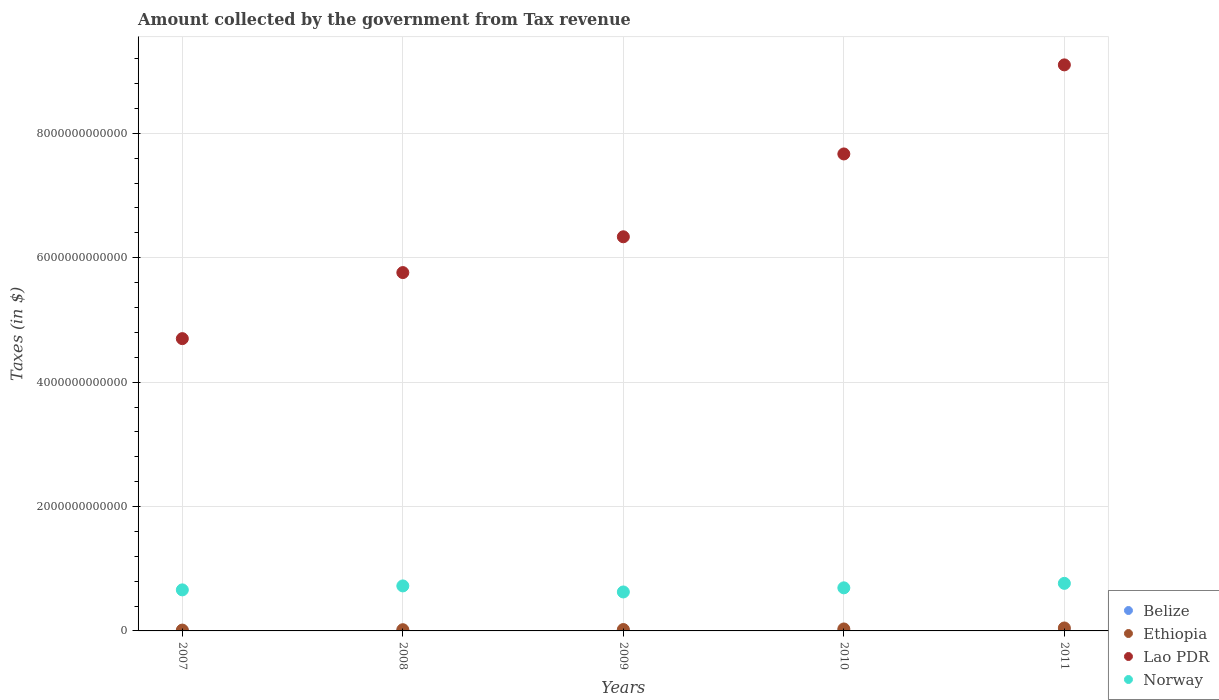How many different coloured dotlines are there?
Your answer should be very brief. 4. What is the amount collected by the government from tax revenue in Belize in 2010?
Provide a short and direct response. 6.59e+08. Across all years, what is the maximum amount collected by the government from tax revenue in Lao PDR?
Give a very brief answer. 9.10e+12. Across all years, what is the minimum amount collected by the government from tax revenue in Norway?
Offer a terse response. 6.26e+11. In which year was the amount collected by the government from tax revenue in Norway minimum?
Keep it short and to the point. 2009. What is the total amount collected by the government from tax revenue in Norway in the graph?
Your answer should be compact. 3.47e+12. What is the difference between the amount collected by the government from tax revenue in Ethiopia in 2009 and that in 2010?
Ensure brevity in your answer.  -9.26e+09. What is the difference between the amount collected by the government from tax revenue in Belize in 2011 and the amount collected by the government from tax revenue in Lao PDR in 2009?
Offer a terse response. -6.34e+12. What is the average amount collected by the government from tax revenue in Lao PDR per year?
Ensure brevity in your answer.  6.71e+12. In the year 2009, what is the difference between the amount collected by the government from tax revenue in Ethiopia and amount collected by the government from tax revenue in Lao PDR?
Your answer should be compact. -6.31e+12. What is the ratio of the amount collected by the government from tax revenue in Lao PDR in 2007 to that in 2010?
Give a very brief answer. 0.61. Is the difference between the amount collected by the government from tax revenue in Ethiopia in 2007 and 2011 greater than the difference between the amount collected by the government from tax revenue in Lao PDR in 2007 and 2011?
Offer a terse response. Yes. What is the difference between the highest and the second highest amount collected by the government from tax revenue in Lao PDR?
Make the answer very short. 1.43e+12. What is the difference between the highest and the lowest amount collected by the government from tax revenue in Belize?
Give a very brief answer. 7.95e+07. Is the sum of the amount collected by the government from tax revenue in Ethiopia in 2008 and 2009 greater than the maximum amount collected by the government from tax revenue in Belize across all years?
Make the answer very short. Yes. What is the difference between two consecutive major ticks on the Y-axis?
Your response must be concise. 2.00e+12. Are the values on the major ticks of Y-axis written in scientific E-notation?
Offer a very short reply. No. Does the graph contain any zero values?
Your answer should be compact. No. How many legend labels are there?
Your answer should be compact. 4. What is the title of the graph?
Ensure brevity in your answer.  Amount collected by the government from Tax revenue. What is the label or title of the X-axis?
Offer a terse response. Years. What is the label or title of the Y-axis?
Ensure brevity in your answer.  Taxes (in $). What is the Taxes (in $) in Belize in 2007?
Keep it short and to the point. 5.92e+08. What is the Taxes (in $) of Ethiopia in 2007?
Your response must be concise. 1.35e+1. What is the Taxes (in $) in Lao PDR in 2007?
Your answer should be compact. 4.70e+12. What is the Taxes (in $) of Norway in 2007?
Your answer should be very brief. 6.60e+11. What is the Taxes (in $) of Belize in 2008?
Provide a short and direct response. 5.94e+08. What is the Taxes (in $) of Ethiopia in 2008?
Give a very brief answer. 1.96e+1. What is the Taxes (in $) of Lao PDR in 2008?
Provide a short and direct response. 5.76e+12. What is the Taxes (in $) in Norway in 2008?
Make the answer very short. 7.24e+11. What is the Taxes (in $) of Belize in 2009?
Give a very brief answer. 6.01e+08. What is the Taxes (in $) of Ethiopia in 2009?
Offer a terse response. 2.22e+1. What is the Taxes (in $) in Lao PDR in 2009?
Offer a very short reply. 6.34e+12. What is the Taxes (in $) of Norway in 2009?
Your answer should be compact. 6.26e+11. What is the Taxes (in $) in Belize in 2010?
Provide a short and direct response. 6.59e+08. What is the Taxes (in $) in Ethiopia in 2010?
Your answer should be very brief. 3.15e+1. What is the Taxes (in $) in Lao PDR in 2010?
Your response must be concise. 7.67e+12. What is the Taxes (in $) of Norway in 2010?
Offer a terse response. 6.93e+11. What is the Taxes (in $) in Belize in 2011?
Offer a terse response. 6.71e+08. What is the Taxes (in $) in Ethiopia in 2011?
Ensure brevity in your answer.  4.74e+1. What is the Taxes (in $) of Lao PDR in 2011?
Give a very brief answer. 9.10e+12. What is the Taxes (in $) in Norway in 2011?
Your answer should be compact. 7.65e+11. Across all years, what is the maximum Taxes (in $) in Belize?
Make the answer very short. 6.71e+08. Across all years, what is the maximum Taxes (in $) of Ethiopia?
Make the answer very short. 4.74e+1. Across all years, what is the maximum Taxes (in $) of Lao PDR?
Your answer should be compact. 9.10e+12. Across all years, what is the maximum Taxes (in $) of Norway?
Provide a short and direct response. 7.65e+11. Across all years, what is the minimum Taxes (in $) in Belize?
Provide a short and direct response. 5.92e+08. Across all years, what is the minimum Taxes (in $) of Ethiopia?
Your response must be concise. 1.35e+1. Across all years, what is the minimum Taxes (in $) of Lao PDR?
Provide a short and direct response. 4.70e+12. Across all years, what is the minimum Taxes (in $) in Norway?
Ensure brevity in your answer.  6.26e+11. What is the total Taxes (in $) in Belize in the graph?
Offer a terse response. 3.12e+09. What is the total Taxes (in $) of Ethiopia in the graph?
Your response must be concise. 1.34e+11. What is the total Taxes (in $) of Lao PDR in the graph?
Provide a short and direct response. 3.36e+13. What is the total Taxes (in $) of Norway in the graph?
Provide a succinct answer. 3.47e+12. What is the difference between the Taxes (in $) in Belize in 2007 and that in 2008?
Your answer should be compact. -2.30e+06. What is the difference between the Taxes (in $) in Ethiopia in 2007 and that in 2008?
Offer a very short reply. -6.01e+09. What is the difference between the Taxes (in $) in Lao PDR in 2007 and that in 2008?
Ensure brevity in your answer.  -1.06e+12. What is the difference between the Taxes (in $) of Norway in 2007 and that in 2008?
Offer a very short reply. -6.36e+1. What is the difference between the Taxes (in $) in Belize in 2007 and that in 2009?
Give a very brief answer. -9.46e+06. What is the difference between the Taxes (in $) of Ethiopia in 2007 and that in 2009?
Ensure brevity in your answer.  -8.70e+09. What is the difference between the Taxes (in $) in Lao PDR in 2007 and that in 2009?
Your response must be concise. -1.64e+12. What is the difference between the Taxes (in $) of Norway in 2007 and that in 2009?
Keep it short and to the point. 3.35e+1. What is the difference between the Taxes (in $) of Belize in 2007 and that in 2010?
Provide a short and direct response. -6.77e+07. What is the difference between the Taxes (in $) in Ethiopia in 2007 and that in 2010?
Provide a succinct answer. -1.80e+1. What is the difference between the Taxes (in $) in Lao PDR in 2007 and that in 2010?
Make the answer very short. -2.97e+12. What is the difference between the Taxes (in $) in Norway in 2007 and that in 2010?
Give a very brief answer. -3.28e+1. What is the difference between the Taxes (in $) of Belize in 2007 and that in 2011?
Ensure brevity in your answer.  -7.95e+07. What is the difference between the Taxes (in $) of Ethiopia in 2007 and that in 2011?
Provide a short and direct response. -3.39e+1. What is the difference between the Taxes (in $) of Lao PDR in 2007 and that in 2011?
Provide a short and direct response. -4.40e+12. What is the difference between the Taxes (in $) in Norway in 2007 and that in 2011?
Keep it short and to the point. -1.05e+11. What is the difference between the Taxes (in $) in Belize in 2008 and that in 2009?
Your response must be concise. -7.17e+06. What is the difference between the Taxes (in $) in Ethiopia in 2008 and that in 2009?
Make the answer very short. -2.69e+09. What is the difference between the Taxes (in $) in Lao PDR in 2008 and that in 2009?
Ensure brevity in your answer.  -5.76e+11. What is the difference between the Taxes (in $) in Norway in 2008 and that in 2009?
Provide a short and direct response. 9.71e+1. What is the difference between the Taxes (in $) in Belize in 2008 and that in 2010?
Give a very brief answer. -6.54e+07. What is the difference between the Taxes (in $) of Ethiopia in 2008 and that in 2010?
Give a very brief answer. -1.19e+1. What is the difference between the Taxes (in $) of Lao PDR in 2008 and that in 2010?
Offer a terse response. -1.91e+12. What is the difference between the Taxes (in $) in Norway in 2008 and that in 2010?
Provide a short and direct response. 3.08e+1. What is the difference between the Taxes (in $) in Belize in 2008 and that in 2011?
Give a very brief answer. -7.72e+07. What is the difference between the Taxes (in $) in Ethiopia in 2008 and that in 2011?
Offer a very short reply. -2.79e+1. What is the difference between the Taxes (in $) of Lao PDR in 2008 and that in 2011?
Give a very brief answer. -3.34e+12. What is the difference between the Taxes (in $) of Norway in 2008 and that in 2011?
Your response must be concise. -4.12e+1. What is the difference between the Taxes (in $) of Belize in 2009 and that in 2010?
Ensure brevity in your answer.  -5.82e+07. What is the difference between the Taxes (in $) of Ethiopia in 2009 and that in 2010?
Offer a very short reply. -9.26e+09. What is the difference between the Taxes (in $) of Lao PDR in 2009 and that in 2010?
Your response must be concise. -1.33e+12. What is the difference between the Taxes (in $) in Norway in 2009 and that in 2010?
Provide a succinct answer. -6.63e+1. What is the difference between the Taxes (in $) in Belize in 2009 and that in 2011?
Keep it short and to the point. -7.00e+07. What is the difference between the Taxes (in $) of Ethiopia in 2009 and that in 2011?
Offer a very short reply. -2.52e+1. What is the difference between the Taxes (in $) in Lao PDR in 2009 and that in 2011?
Provide a short and direct response. -2.76e+12. What is the difference between the Taxes (in $) in Norway in 2009 and that in 2011?
Offer a terse response. -1.38e+11. What is the difference between the Taxes (in $) in Belize in 2010 and that in 2011?
Your answer should be compact. -1.18e+07. What is the difference between the Taxes (in $) of Ethiopia in 2010 and that in 2011?
Ensure brevity in your answer.  -1.59e+1. What is the difference between the Taxes (in $) of Lao PDR in 2010 and that in 2011?
Give a very brief answer. -1.43e+12. What is the difference between the Taxes (in $) of Norway in 2010 and that in 2011?
Provide a short and direct response. -7.20e+1. What is the difference between the Taxes (in $) in Belize in 2007 and the Taxes (in $) in Ethiopia in 2008?
Your answer should be compact. -1.90e+1. What is the difference between the Taxes (in $) of Belize in 2007 and the Taxes (in $) of Lao PDR in 2008?
Keep it short and to the point. -5.76e+12. What is the difference between the Taxes (in $) in Belize in 2007 and the Taxes (in $) in Norway in 2008?
Ensure brevity in your answer.  -7.23e+11. What is the difference between the Taxes (in $) of Ethiopia in 2007 and the Taxes (in $) of Lao PDR in 2008?
Ensure brevity in your answer.  -5.75e+12. What is the difference between the Taxes (in $) in Ethiopia in 2007 and the Taxes (in $) in Norway in 2008?
Your answer should be very brief. -7.10e+11. What is the difference between the Taxes (in $) in Lao PDR in 2007 and the Taxes (in $) in Norway in 2008?
Keep it short and to the point. 3.98e+12. What is the difference between the Taxes (in $) in Belize in 2007 and the Taxes (in $) in Ethiopia in 2009?
Offer a very short reply. -2.17e+1. What is the difference between the Taxes (in $) in Belize in 2007 and the Taxes (in $) in Lao PDR in 2009?
Make the answer very short. -6.34e+12. What is the difference between the Taxes (in $) in Belize in 2007 and the Taxes (in $) in Norway in 2009?
Offer a very short reply. -6.26e+11. What is the difference between the Taxes (in $) in Ethiopia in 2007 and the Taxes (in $) in Lao PDR in 2009?
Make the answer very short. -6.32e+12. What is the difference between the Taxes (in $) of Ethiopia in 2007 and the Taxes (in $) of Norway in 2009?
Offer a terse response. -6.13e+11. What is the difference between the Taxes (in $) of Lao PDR in 2007 and the Taxes (in $) of Norway in 2009?
Provide a succinct answer. 4.07e+12. What is the difference between the Taxes (in $) of Belize in 2007 and the Taxes (in $) of Ethiopia in 2010?
Ensure brevity in your answer.  -3.09e+1. What is the difference between the Taxes (in $) in Belize in 2007 and the Taxes (in $) in Lao PDR in 2010?
Make the answer very short. -7.67e+12. What is the difference between the Taxes (in $) of Belize in 2007 and the Taxes (in $) of Norway in 2010?
Offer a very short reply. -6.92e+11. What is the difference between the Taxes (in $) in Ethiopia in 2007 and the Taxes (in $) in Lao PDR in 2010?
Your response must be concise. -7.66e+12. What is the difference between the Taxes (in $) in Ethiopia in 2007 and the Taxes (in $) in Norway in 2010?
Ensure brevity in your answer.  -6.79e+11. What is the difference between the Taxes (in $) of Lao PDR in 2007 and the Taxes (in $) of Norway in 2010?
Your answer should be very brief. 4.01e+12. What is the difference between the Taxes (in $) in Belize in 2007 and the Taxes (in $) in Ethiopia in 2011?
Provide a succinct answer. -4.68e+1. What is the difference between the Taxes (in $) in Belize in 2007 and the Taxes (in $) in Lao PDR in 2011?
Ensure brevity in your answer.  -9.10e+12. What is the difference between the Taxes (in $) of Belize in 2007 and the Taxes (in $) of Norway in 2011?
Your response must be concise. -7.64e+11. What is the difference between the Taxes (in $) in Ethiopia in 2007 and the Taxes (in $) in Lao PDR in 2011?
Provide a short and direct response. -9.09e+12. What is the difference between the Taxes (in $) of Ethiopia in 2007 and the Taxes (in $) of Norway in 2011?
Provide a succinct answer. -7.51e+11. What is the difference between the Taxes (in $) of Lao PDR in 2007 and the Taxes (in $) of Norway in 2011?
Keep it short and to the point. 3.93e+12. What is the difference between the Taxes (in $) of Belize in 2008 and the Taxes (in $) of Ethiopia in 2009?
Offer a very short reply. -2.16e+1. What is the difference between the Taxes (in $) of Belize in 2008 and the Taxes (in $) of Lao PDR in 2009?
Provide a succinct answer. -6.34e+12. What is the difference between the Taxes (in $) of Belize in 2008 and the Taxes (in $) of Norway in 2009?
Give a very brief answer. -6.26e+11. What is the difference between the Taxes (in $) in Ethiopia in 2008 and the Taxes (in $) in Lao PDR in 2009?
Provide a succinct answer. -6.32e+12. What is the difference between the Taxes (in $) of Ethiopia in 2008 and the Taxes (in $) of Norway in 2009?
Provide a succinct answer. -6.07e+11. What is the difference between the Taxes (in $) in Lao PDR in 2008 and the Taxes (in $) in Norway in 2009?
Offer a very short reply. 5.13e+12. What is the difference between the Taxes (in $) in Belize in 2008 and the Taxes (in $) in Ethiopia in 2010?
Give a very brief answer. -3.09e+1. What is the difference between the Taxes (in $) in Belize in 2008 and the Taxes (in $) in Lao PDR in 2010?
Your response must be concise. -7.67e+12. What is the difference between the Taxes (in $) of Belize in 2008 and the Taxes (in $) of Norway in 2010?
Ensure brevity in your answer.  -6.92e+11. What is the difference between the Taxes (in $) of Ethiopia in 2008 and the Taxes (in $) of Lao PDR in 2010?
Give a very brief answer. -7.65e+12. What is the difference between the Taxes (in $) in Ethiopia in 2008 and the Taxes (in $) in Norway in 2010?
Make the answer very short. -6.73e+11. What is the difference between the Taxes (in $) of Lao PDR in 2008 and the Taxes (in $) of Norway in 2010?
Ensure brevity in your answer.  5.07e+12. What is the difference between the Taxes (in $) of Belize in 2008 and the Taxes (in $) of Ethiopia in 2011?
Offer a terse response. -4.68e+1. What is the difference between the Taxes (in $) in Belize in 2008 and the Taxes (in $) in Lao PDR in 2011?
Offer a very short reply. -9.10e+12. What is the difference between the Taxes (in $) of Belize in 2008 and the Taxes (in $) of Norway in 2011?
Your answer should be compact. -7.64e+11. What is the difference between the Taxes (in $) of Ethiopia in 2008 and the Taxes (in $) of Lao PDR in 2011?
Keep it short and to the point. -9.08e+12. What is the difference between the Taxes (in $) of Ethiopia in 2008 and the Taxes (in $) of Norway in 2011?
Offer a very short reply. -7.45e+11. What is the difference between the Taxes (in $) in Lao PDR in 2008 and the Taxes (in $) in Norway in 2011?
Your answer should be compact. 5.00e+12. What is the difference between the Taxes (in $) of Belize in 2009 and the Taxes (in $) of Ethiopia in 2010?
Your answer should be very brief. -3.09e+1. What is the difference between the Taxes (in $) in Belize in 2009 and the Taxes (in $) in Lao PDR in 2010?
Ensure brevity in your answer.  -7.67e+12. What is the difference between the Taxes (in $) of Belize in 2009 and the Taxes (in $) of Norway in 2010?
Ensure brevity in your answer.  -6.92e+11. What is the difference between the Taxes (in $) of Ethiopia in 2009 and the Taxes (in $) of Lao PDR in 2010?
Provide a succinct answer. -7.65e+12. What is the difference between the Taxes (in $) of Ethiopia in 2009 and the Taxes (in $) of Norway in 2010?
Ensure brevity in your answer.  -6.70e+11. What is the difference between the Taxes (in $) of Lao PDR in 2009 and the Taxes (in $) of Norway in 2010?
Ensure brevity in your answer.  5.64e+12. What is the difference between the Taxes (in $) in Belize in 2009 and the Taxes (in $) in Ethiopia in 2011?
Offer a very short reply. -4.68e+1. What is the difference between the Taxes (in $) of Belize in 2009 and the Taxes (in $) of Lao PDR in 2011?
Ensure brevity in your answer.  -9.10e+12. What is the difference between the Taxes (in $) of Belize in 2009 and the Taxes (in $) of Norway in 2011?
Your answer should be very brief. -7.64e+11. What is the difference between the Taxes (in $) of Ethiopia in 2009 and the Taxes (in $) of Lao PDR in 2011?
Offer a terse response. -9.08e+12. What is the difference between the Taxes (in $) of Ethiopia in 2009 and the Taxes (in $) of Norway in 2011?
Offer a very short reply. -7.42e+11. What is the difference between the Taxes (in $) of Lao PDR in 2009 and the Taxes (in $) of Norway in 2011?
Make the answer very short. 5.57e+12. What is the difference between the Taxes (in $) in Belize in 2010 and the Taxes (in $) in Ethiopia in 2011?
Make the answer very short. -4.68e+1. What is the difference between the Taxes (in $) of Belize in 2010 and the Taxes (in $) of Lao PDR in 2011?
Your answer should be very brief. -9.10e+12. What is the difference between the Taxes (in $) in Belize in 2010 and the Taxes (in $) in Norway in 2011?
Ensure brevity in your answer.  -7.64e+11. What is the difference between the Taxes (in $) in Ethiopia in 2010 and the Taxes (in $) in Lao PDR in 2011?
Make the answer very short. -9.07e+12. What is the difference between the Taxes (in $) of Ethiopia in 2010 and the Taxes (in $) of Norway in 2011?
Provide a short and direct response. -7.33e+11. What is the difference between the Taxes (in $) of Lao PDR in 2010 and the Taxes (in $) of Norway in 2011?
Ensure brevity in your answer.  6.90e+12. What is the average Taxes (in $) in Belize per year?
Give a very brief answer. 6.23e+08. What is the average Taxes (in $) in Ethiopia per year?
Offer a very short reply. 2.69e+1. What is the average Taxes (in $) in Lao PDR per year?
Provide a succinct answer. 6.71e+12. What is the average Taxes (in $) of Norway per year?
Your answer should be very brief. 6.93e+11. In the year 2007, what is the difference between the Taxes (in $) of Belize and Taxes (in $) of Ethiopia?
Offer a very short reply. -1.29e+1. In the year 2007, what is the difference between the Taxes (in $) of Belize and Taxes (in $) of Lao PDR?
Provide a succinct answer. -4.70e+12. In the year 2007, what is the difference between the Taxes (in $) in Belize and Taxes (in $) in Norway?
Offer a very short reply. -6.59e+11. In the year 2007, what is the difference between the Taxes (in $) in Ethiopia and Taxes (in $) in Lao PDR?
Your answer should be very brief. -4.69e+12. In the year 2007, what is the difference between the Taxes (in $) in Ethiopia and Taxes (in $) in Norway?
Give a very brief answer. -6.46e+11. In the year 2007, what is the difference between the Taxes (in $) of Lao PDR and Taxes (in $) of Norway?
Provide a succinct answer. 4.04e+12. In the year 2008, what is the difference between the Taxes (in $) in Belize and Taxes (in $) in Ethiopia?
Make the answer very short. -1.90e+1. In the year 2008, what is the difference between the Taxes (in $) in Belize and Taxes (in $) in Lao PDR?
Make the answer very short. -5.76e+12. In the year 2008, what is the difference between the Taxes (in $) in Belize and Taxes (in $) in Norway?
Ensure brevity in your answer.  -7.23e+11. In the year 2008, what is the difference between the Taxes (in $) in Ethiopia and Taxes (in $) in Lao PDR?
Offer a very short reply. -5.74e+12. In the year 2008, what is the difference between the Taxes (in $) of Ethiopia and Taxes (in $) of Norway?
Make the answer very short. -7.04e+11. In the year 2008, what is the difference between the Taxes (in $) in Lao PDR and Taxes (in $) in Norway?
Your answer should be very brief. 5.04e+12. In the year 2009, what is the difference between the Taxes (in $) in Belize and Taxes (in $) in Ethiopia?
Give a very brief answer. -2.16e+1. In the year 2009, what is the difference between the Taxes (in $) in Belize and Taxes (in $) in Lao PDR?
Give a very brief answer. -6.34e+12. In the year 2009, what is the difference between the Taxes (in $) of Belize and Taxes (in $) of Norway?
Provide a succinct answer. -6.26e+11. In the year 2009, what is the difference between the Taxes (in $) in Ethiopia and Taxes (in $) in Lao PDR?
Give a very brief answer. -6.31e+12. In the year 2009, what is the difference between the Taxes (in $) of Ethiopia and Taxes (in $) of Norway?
Give a very brief answer. -6.04e+11. In the year 2009, what is the difference between the Taxes (in $) of Lao PDR and Taxes (in $) of Norway?
Your answer should be very brief. 5.71e+12. In the year 2010, what is the difference between the Taxes (in $) of Belize and Taxes (in $) of Ethiopia?
Ensure brevity in your answer.  -3.08e+1. In the year 2010, what is the difference between the Taxes (in $) of Belize and Taxes (in $) of Lao PDR?
Provide a short and direct response. -7.67e+12. In the year 2010, what is the difference between the Taxes (in $) in Belize and Taxes (in $) in Norway?
Ensure brevity in your answer.  -6.92e+11. In the year 2010, what is the difference between the Taxes (in $) in Ethiopia and Taxes (in $) in Lao PDR?
Provide a succinct answer. -7.64e+12. In the year 2010, what is the difference between the Taxes (in $) of Ethiopia and Taxes (in $) of Norway?
Provide a succinct answer. -6.61e+11. In the year 2010, what is the difference between the Taxes (in $) in Lao PDR and Taxes (in $) in Norway?
Provide a succinct answer. 6.98e+12. In the year 2011, what is the difference between the Taxes (in $) of Belize and Taxes (in $) of Ethiopia?
Your response must be concise. -4.68e+1. In the year 2011, what is the difference between the Taxes (in $) in Belize and Taxes (in $) in Lao PDR?
Make the answer very short. -9.10e+12. In the year 2011, what is the difference between the Taxes (in $) in Belize and Taxes (in $) in Norway?
Keep it short and to the point. -7.64e+11. In the year 2011, what is the difference between the Taxes (in $) in Ethiopia and Taxes (in $) in Lao PDR?
Offer a terse response. -9.05e+12. In the year 2011, what is the difference between the Taxes (in $) in Ethiopia and Taxes (in $) in Norway?
Provide a short and direct response. -7.17e+11. In the year 2011, what is the difference between the Taxes (in $) in Lao PDR and Taxes (in $) in Norway?
Your answer should be very brief. 8.34e+12. What is the ratio of the Taxes (in $) of Ethiopia in 2007 to that in 2008?
Offer a very short reply. 0.69. What is the ratio of the Taxes (in $) in Lao PDR in 2007 to that in 2008?
Offer a terse response. 0.82. What is the ratio of the Taxes (in $) of Norway in 2007 to that in 2008?
Offer a very short reply. 0.91. What is the ratio of the Taxes (in $) in Belize in 2007 to that in 2009?
Provide a succinct answer. 0.98. What is the ratio of the Taxes (in $) in Ethiopia in 2007 to that in 2009?
Ensure brevity in your answer.  0.61. What is the ratio of the Taxes (in $) in Lao PDR in 2007 to that in 2009?
Provide a succinct answer. 0.74. What is the ratio of the Taxes (in $) in Norway in 2007 to that in 2009?
Your response must be concise. 1.05. What is the ratio of the Taxes (in $) in Belize in 2007 to that in 2010?
Give a very brief answer. 0.9. What is the ratio of the Taxes (in $) in Ethiopia in 2007 to that in 2010?
Offer a terse response. 0.43. What is the ratio of the Taxes (in $) in Lao PDR in 2007 to that in 2010?
Keep it short and to the point. 0.61. What is the ratio of the Taxes (in $) of Norway in 2007 to that in 2010?
Your answer should be very brief. 0.95. What is the ratio of the Taxes (in $) of Belize in 2007 to that in 2011?
Your answer should be compact. 0.88. What is the ratio of the Taxes (in $) in Ethiopia in 2007 to that in 2011?
Your response must be concise. 0.29. What is the ratio of the Taxes (in $) in Lao PDR in 2007 to that in 2011?
Your answer should be very brief. 0.52. What is the ratio of the Taxes (in $) in Norway in 2007 to that in 2011?
Offer a very short reply. 0.86. What is the ratio of the Taxes (in $) in Belize in 2008 to that in 2009?
Provide a succinct answer. 0.99. What is the ratio of the Taxes (in $) of Ethiopia in 2008 to that in 2009?
Give a very brief answer. 0.88. What is the ratio of the Taxes (in $) of Lao PDR in 2008 to that in 2009?
Your answer should be very brief. 0.91. What is the ratio of the Taxes (in $) of Norway in 2008 to that in 2009?
Provide a succinct answer. 1.16. What is the ratio of the Taxes (in $) in Belize in 2008 to that in 2010?
Make the answer very short. 0.9. What is the ratio of the Taxes (in $) in Ethiopia in 2008 to that in 2010?
Ensure brevity in your answer.  0.62. What is the ratio of the Taxes (in $) in Lao PDR in 2008 to that in 2010?
Ensure brevity in your answer.  0.75. What is the ratio of the Taxes (in $) in Norway in 2008 to that in 2010?
Provide a short and direct response. 1.04. What is the ratio of the Taxes (in $) in Belize in 2008 to that in 2011?
Offer a terse response. 0.89. What is the ratio of the Taxes (in $) in Ethiopia in 2008 to that in 2011?
Offer a terse response. 0.41. What is the ratio of the Taxes (in $) in Lao PDR in 2008 to that in 2011?
Your answer should be very brief. 0.63. What is the ratio of the Taxes (in $) of Norway in 2008 to that in 2011?
Your answer should be compact. 0.95. What is the ratio of the Taxes (in $) of Belize in 2009 to that in 2010?
Ensure brevity in your answer.  0.91. What is the ratio of the Taxes (in $) of Ethiopia in 2009 to that in 2010?
Your response must be concise. 0.71. What is the ratio of the Taxes (in $) of Lao PDR in 2009 to that in 2010?
Your answer should be compact. 0.83. What is the ratio of the Taxes (in $) in Norway in 2009 to that in 2010?
Ensure brevity in your answer.  0.9. What is the ratio of the Taxes (in $) in Belize in 2009 to that in 2011?
Your response must be concise. 0.9. What is the ratio of the Taxes (in $) in Ethiopia in 2009 to that in 2011?
Keep it short and to the point. 0.47. What is the ratio of the Taxes (in $) in Lao PDR in 2009 to that in 2011?
Keep it short and to the point. 0.7. What is the ratio of the Taxes (in $) of Norway in 2009 to that in 2011?
Offer a terse response. 0.82. What is the ratio of the Taxes (in $) of Belize in 2010 to that in 2011?
Provide a succinct answer. 0.98. What is the ratio of the Taxes (in $) of Ethiopia in 2010 to that in 2011?
Your answer should be very brief. 0.66. What is the ratio of the Taxes (in $) in Lao PDR in 2010 to that in 2011?
Offer a very short reply. 0.84. What is the ratio of the Taxes (in $) of Norway in 2010 to that in 2011?
Ensure brevity in your answer.  0.91. What is the difference between the highest and the second highest Taxes (in $) of Belize?
Ensure brevity in your answer.  1.18e+07. What is the difference between the highest and the second highest Taxes (in $) in Ethiopia?
Offer a terse response. 1.59e+1. What is the difference between the highest and the second highest Taxes (in $) of Lao PDR?
Ensure brevity in your answer.  1.43e+12. What is the difference between the highest and the second highest Taxes (in $) in Norway?
Provide a short and direct response. 4.12e+1. What is the difference between the highest and the lowest Taxes (in $) of Belize?
Your answer should be very brief. 7.95e+07. What is the difference between the highest and the lowest Taxes (in $) in Ethiopia?
Provide a short and direct response. 3.39e+1. What is the difference between the highest and the lowest Taxes (in $) in Lao PDR?
Your response must be concise. 4.40e+12. What is the difference between the highest and the lowest Taxes (in $) in Norway?
Offer a very short reply. 1.38e+11. 